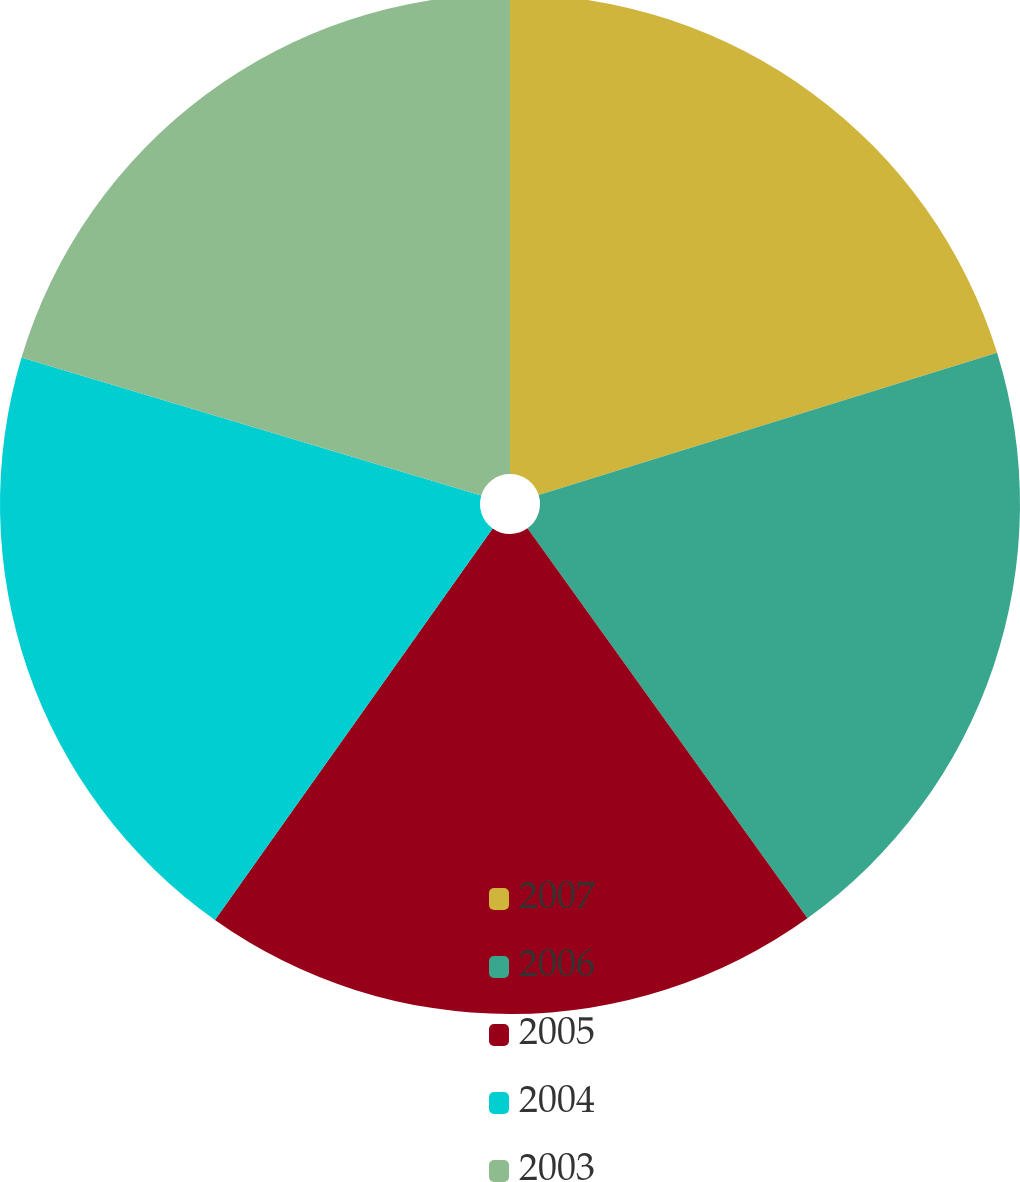Convert chart. <chart><loc_0><loc_0><loc_500><loc_500><pie_chart><fcel>2007<fcel>2006<fcel>2005<fcel>2004<fcel>2003<nl><fcel>20.21%<fcel>19.88%<fcel>19.73%<fcel>19.82%<fcel>20.36%<nl></chart> 